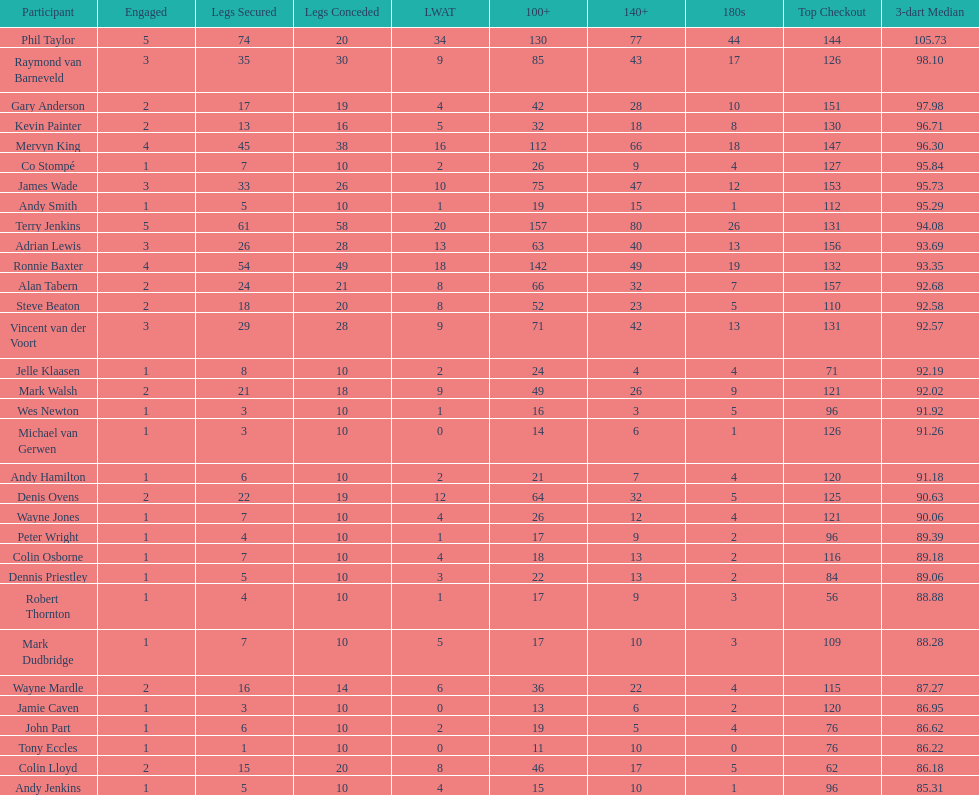Write the full table. {'header': ['Participant', 'Engaged', 'Legs Secured', 'Legs Conceded', 'LWAT', '100+', '140+', '180s', 'Top Checkout', '3-dart Median'], 'rows': [['Phil Taylor', '5', '74', '20', '34', '130', '77', '44', '144', '105.73'], ['Raymond van Barneveld', '3', '35', '30', '9', '85', '43', '17', '126', '98.10'], ['Gary Anderson', '2', '17', '19', '4', '42', '28', '10', '151', '97.98'], ['Kevin Painter', '2', '13', '16', '5', '32', '18', '8', '130', '96.71'], ['Mervyn King', '4', '45', '38', '16', '112', '66', '18', '147', '96.30'], ['Co Stompé', '1', '7', '10', '2', '26', '9', '4', '127', '95.84'], ['James Wade', '3', '33', '26', '10', '75', '47', '12', '153', '95.73'], ['Andy Smith', '1', '5', '10', '1', '19', '15', '1', '112', '95.29'], ['Terry Jenkins', '5', '61', '58', '20', '157', '80', '26', '131', '94.08'], ['Adrian Lewis', '3', '26', '28', '13', '63', '40', '13', '156', '93.69'], ['Ronnie Baxter', '4', '54', '49', '18', '142', '49', '19', '132', '93.35'], ['Alan Tabern', '2', '24', '21', '8', '66', '32', '7', '157', '92.68'], ['Steve Beaton', '2', '18', '20', '8', '52', '23', '5', '110', '92.58'], ['Vincent van der Voort', '3', '29', '28', '9', '71', '42', '13', '131', '92.57'], ['Jelle Klaasen', '1', '8', '10', '2', '24', '4', '4', '71', '92.19'], ['Mark Walsh', '2', '21', '18', '9', '49', '26', '9', '121', '92.02'], ['Wes Newton', '1', '3', '10', '1', '16', '3', '5', '96', '91.92'], ['Michael van Gerwen', '1', '3', '10', '0', '14', '6', '1', '126', '91.26'], ['Andy Hamilton', '1', '6', '10', '2', '21', '7', '4', '120', '91.18'], ['Denis Ovens', '2', '22', '19', '12', '64', '32', '5', '125', '90.63'], ['Wayne Jones', '1', '7', '10', '4', '26', '12', '4', '121', '90.06'], ['Peter Wright', '1', '4', '10', '1', '17', '9', '2', '96', '89.39'], ['Colin Osborne', '1', '7', '10', '4', '18', '13', '2', '116', '89.18'], ['Dennis Priestley', '1', '5', '10', '3', '22', '13', '2', '84', '89.06'], ['Robert Thornton', '1', '4', '10', '1', '17', '9', '3', '56', '88.88'], ['Mark Dudbridge', '1', '7', '10', '5', '17', '10', '3', '109', '88.28'], ['Wayne Mardle', '2', '16', '14', '6', '36', '22', '4', '115', '87.27'], ['Jamie Caven', '1', '3', '10', '0', '13', '6', '2', '120', '86.95'], ['John Part', '1', '6', '10', '2', '19', '5', '4', '76', '86.62'], ['Tony Eccles', '1', '1', '10', '0', '11', '10', '0', '76', '86.22'], ['Colin Lloyd', '2', '15', '20', '8', '46', '17', '5', '62', '86.18'], ['Andy Jenkins', '1', '5', '10', '4', '15', '10', '1', '96', '85.31']]} What are the number of legs lost by james wade? 26. 